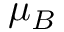<formula> <loc_0><loc_0><loc_500><loc_500>\mu _ { B }</formula> 